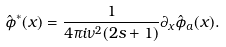Convert formula to latex. <formula><loc_0><loc_0><loc_500><loc_500>\hat { \phi } ^ { * } ( x ) = \frac { 1 } { 4 \pi i \nu ^ { 2 } ( 2 s + 1 ) } \partial _ { x } \hat { \phi } _ { a } ( x ) .</formula> 